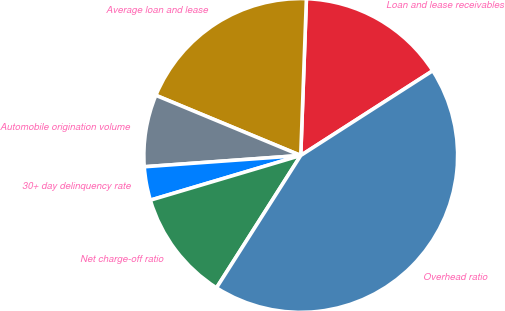<chart> <loc_0><loc_0><loc_500><loc_500><pie_chart><fcel>Loan and lease receivables<fcel>Average loan and lease<fcel>Automobile origination volume<fcel>30+ day delinquency rate<fcel>Net charge-off ratio<fcel>Overhead ratio<nl><fcel>15.34%<fcel>19.31%<fcel>7.41%<fcel>3.45%<fcel>11.38%<fcel>43.1%<nl></chart> 